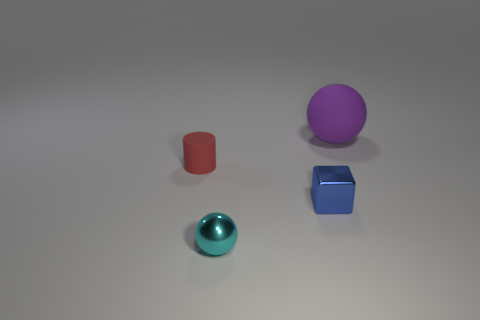Is there anything else that has the same size as the purple matte sphere?
Your answer should be compact. No. Are there fewer blue shiny blocks that are in front of the tiny red matte thing than tiny spheres that are to the right of the blue cube?
Your answer should be compact. No. There is a rubber thing left of the matte object right of the cyan object; what shape is it?
Offer a terse response. Cylinder. Are there any other things that have the same color as the metal ball?
Give a very brief answer. No. Is the color of the tiny rubber object the same as the tiny ball?
Keep it short and to the point. No. How many red objects are small things or tiny shiny cubes?
Offer a very short reply. 1. Are there fewer large purple rubber things on the left side of the small metal sphere than blue metal cubes?
Your answer should be very brief. Yes. There is a shiny sphere that is in front of the matte cylinder; what number of tiny metallic things are in front of it?
Make the answer very short. 0. What number of other things are there of the same size as the red object?
Provide a short and direct response. 2. What number of things are either large purple things or balls that are in front of the tiny blue metal thing?
Give a very brief answer. 2. 